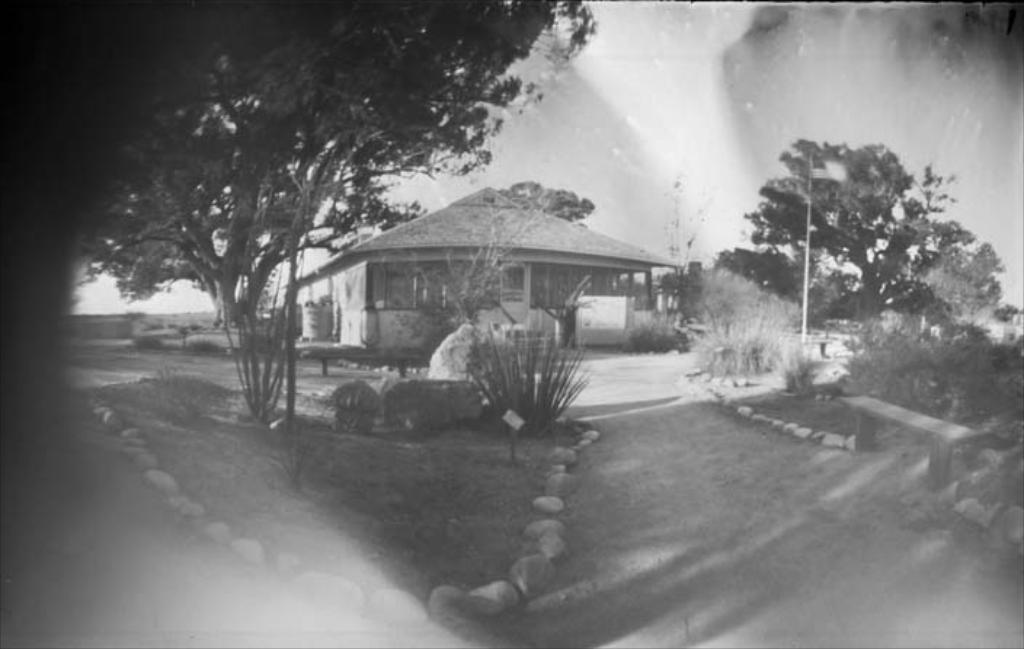Could you give a brief overview of what you see in this image? In the image in the center we can see one house,roof,wall,tank,banner,door and stones. In the background we can see sky,clouds,trees,poles,plants,stones,grass,bench etc. 